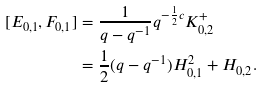<formula> <loc_0><loc_0><loc_500><loc_500>[ E _ { 0 , 1 } , F _ { 0 , 1 } ] & = \frac { 1 } { q - q ^ { - 1 } } q ^ { - \frac { 1 } { 2 } c } K ^ { + } _ { 0 , 2 } \\ & = \frac { 1 } { 2 } ( q - q ^ { - 1 } ) H _ { 0 , 1 } ^ { 2 } + H _ { 0 , 2 } .</formula> 